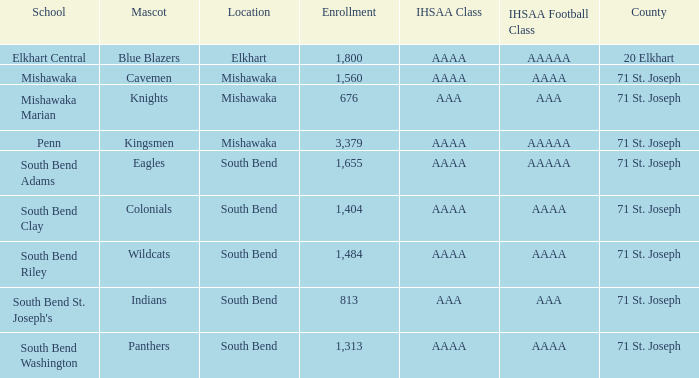What school has south bend as the location, with indians as the mascot? South Bend St. Joseph's. 